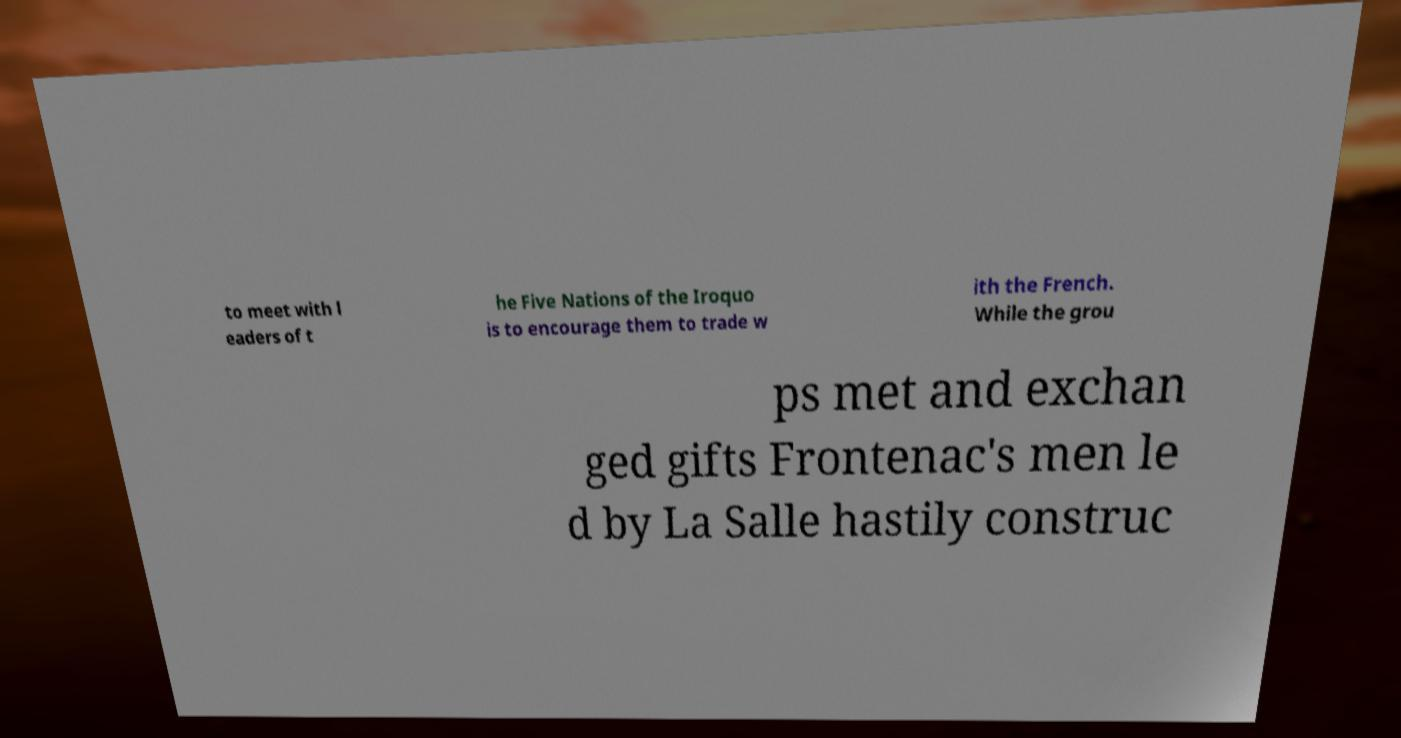Please read and relay the text visible in this image. What does it say? to meet with l eaders of t he Five Nations of the Iroquo is to encourage them to trade w ith the French. While the grou ps met and exchan ged gifts Frontenac's men le d by La Salle hastily construc 